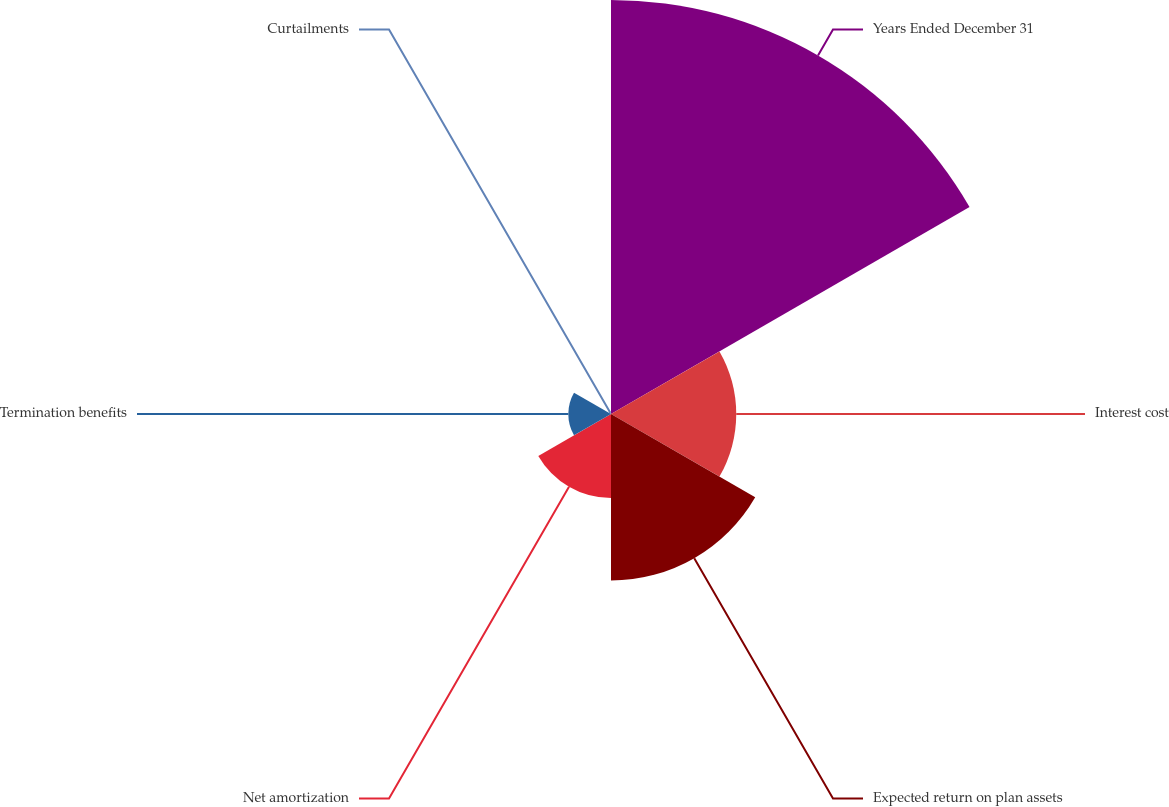Convert chart to OTSL. <chart><loc_0><loc_0><loc_500><loc_500><pie_chart><fcel>Years Ended December 31<fcel>Interest cost<fcel>Expected return on plan assets<fcel>Net amortization<fcel>Termination benefits<fcel>Curtailments<nl><fcel>49.65%<fcel>15.02%<fcel>19.97%<fcel>10.07%<fcel>5.12%<fcel>0.17%<nl></chart> 